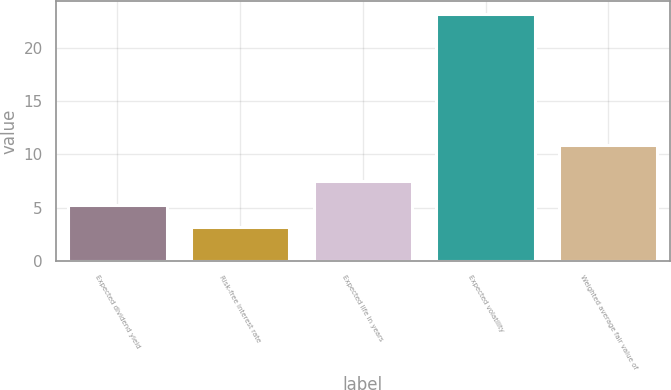<chart> <loc_0><loc_0><loc_500><loc_500><bar_chart><fcel>Expected dividend yield<fcel>Risk-free interest rate<fcel>Expected life in years<fcel>Expected volatility<fcel>Weighted average fair value of<nl><fcel>5.21<fcel>3.22<fcel>7.5<fcel>23.16<fcel>10.86<nl></chart> 